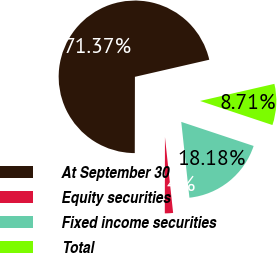<chart> <loc_0><loc_0><loc_500><loc_500><pie_chart><fcel>At September 30<fcel>Equity securities<fcel>Fixed income securities<fcel>Total<nl><fcel>71.37%<fcel>1.74%<fcel>18.18%<fcel>8.71%<nl></chart> 